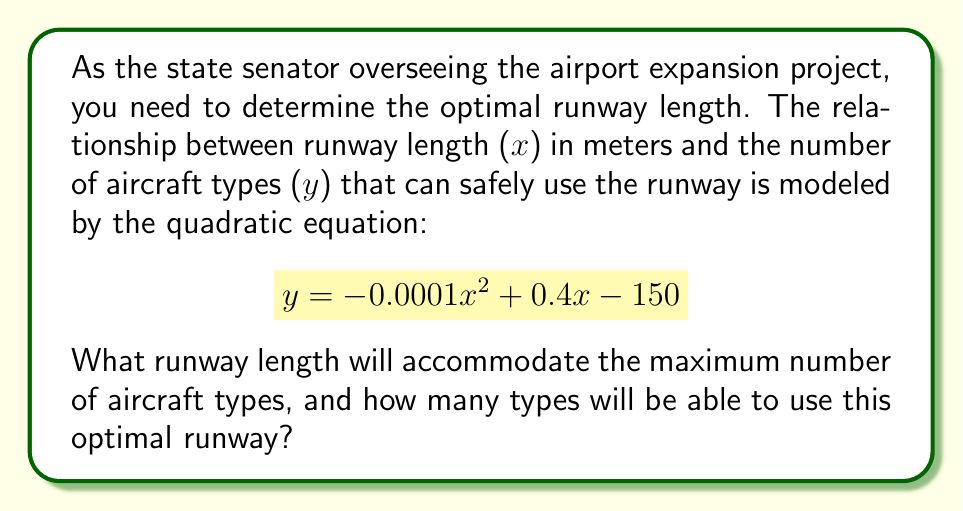Show me your answer to this math problem. To find the optimal runway length, we need to determine the vertex of the parabola, which represents the maximum point of the quadratic function.

Step 1: Identify the quadratic equation in standard form
$$y = ax^2 + bx + c$$
where $a = -0.0001$, $b = 0.4$, and $c = -150$

Step 2: Calculate the x-coordinate of the vertex using the formula $x = -\frac{b}{2a}$
$$x = -\frac{0.4}{2(-0.0001)} = -\frac{0.4}{-0.0002} = 2000$$

Step 3: Calculate the y-coordinate of the vertex by plugging the x-value into the original equation
$$\begin{align}
y &= -0.0001(2000)^2 + 0.4(2000) - 150 \\
&= -0.0001(4,000,000) + 800 - 150 \\
&= -400 + 800 - 150 \\
&= 250
\end{align}$$

Therefore, the optimal runway length is 2000 meters, which will accommodate 250 aircraft types.
Answer: 2000 meters; 250 aircraft types 